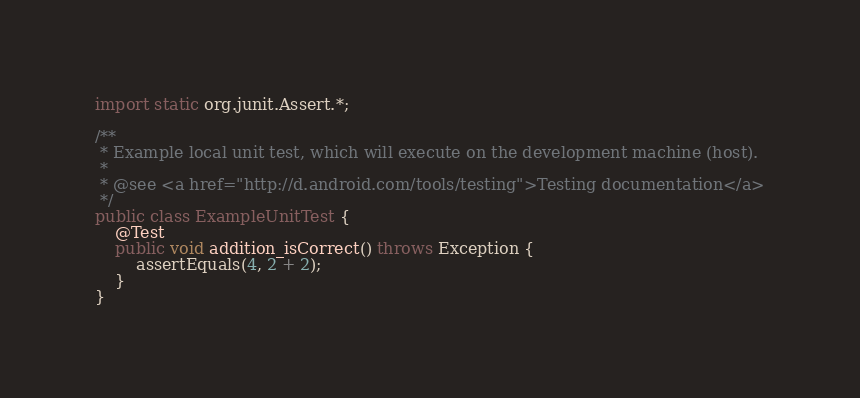Convert code to text. <code><loc_0><loc_0><loc_500><loc_500><_Java_>
import static org.junit.Assert.*;

/**
 * Example local unit test, which will execute on the development machine (host).
 *
 * @see <a href="http://d.android.com/tools/testing">Testing documentation</a>
 */
public class ExampleUnitTest {
    @Test
    public void addition_isCorrect() throws Exception {
        assertEquals(4, 2 + 2);
    }
}</code> 